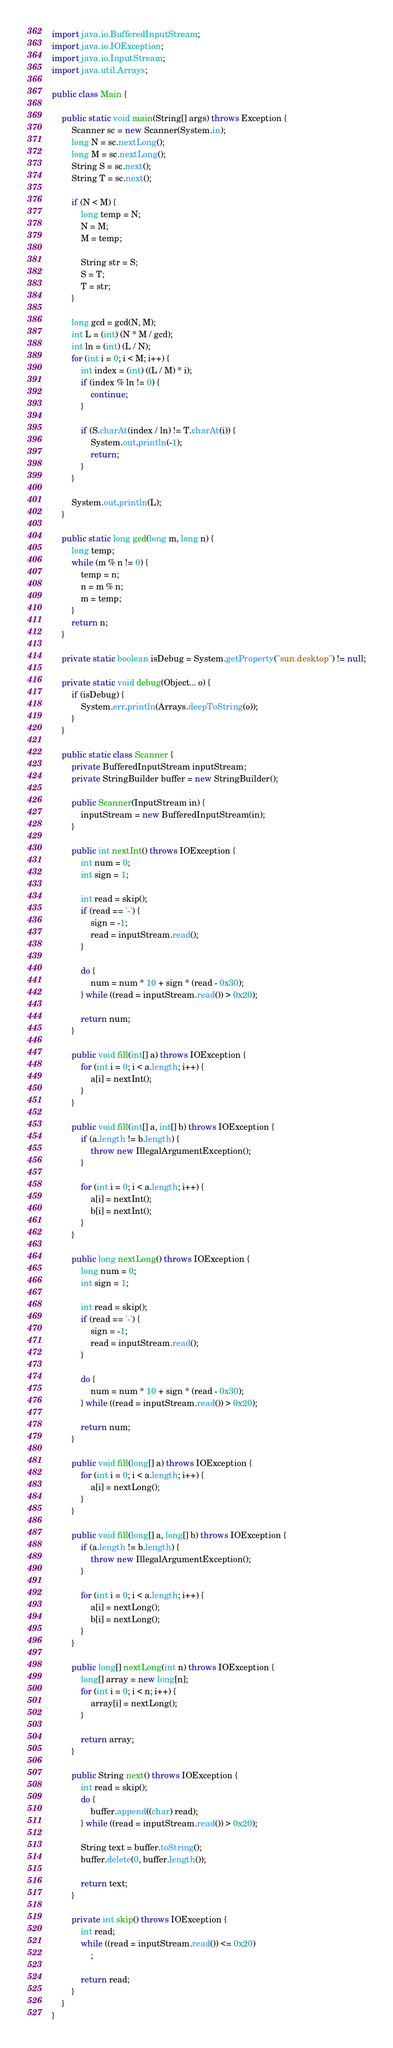<code> <loc_0><loc_0><loc_500><loc_500><_Java_>import java.io.BufferedInputStream;
import java.io.IOException;
import java.io.InputStream;
import java.util.Arrays;

public class Main {

	public static void main(String[] args) throws Exception {
		Scanner sc = new Scanner(System.in);
		long N = sc.nextLong();
		long M = sc.nextLong();
		String S = sc.next();
		String T = sc.next();

		if (N < M) {
			long temp = N;
			N = M;
			M = temp;

			String str = S;
			S = T;
			T = str;
		}

		long gcd = gcd(N, M);
		int L = (int) (N * M / gcd);
		int ln = (int) (L / N);
		for (int i = 0; i < M; i++) {
			int index = (int) ((L / M) * i);
			if (index % ln != 0) {
				continue;
			}

			if (S.charAt(index / ln) != T.charAt(i)) {
				System.out.println(-1);
				return;
			}
		}

		System.out.println(L);
	}

	public static long gcd(long m, long n) {
		long temp;
		while (m % n != 0) {
			temp = n;
			n = m % n;
			m = temp;
		}
		return n;
	}

	private static boolean isDebug = System.getProperty("sun.desktop") != null;

	private static void debug(Object... o) {
		if (isDebug) {
			System.err.println(Arrays.deepToString(o));
		}
	}

	public static class Scanner {
		private BufferedInputStream inputStream;
		private StringBuilder buffer = new StringBuilder();

		public Scanner(InputStream in) {
			inputStream = new BufferedInputStream(in);
		}

		public int nextInt() throws IOException {
			int num = 0;
			int sign = 1;

			int read = skip();
			if (read == '-') {
				sign = -1;
				read = inputStream.read();
			}

			do {
				num = num * 10 + sign * (read - 0x30);
			} while ((read = inputStream.read()) > 0x20);

			return num;
		}

		public void fill(int[] a) throws IOException {
			for (int i = 0; i < a.length; i++) {
				a[i] = nextInt();
			}
		}

		public void fill(int[] a, int[] b) throws IOException {
			if (a.length != b.length) {
				throw new IllegalArgumentException();
			}

			for (int i = 0; i < a.length; i++) {
				a[i] = nextInt();
				b[i] = nextInt();
			}
		}

		public long nextLong() throws IOException {
			long num = 0;
			int sign = 1;

			int read = skip();
			if (read == '-') {
				sign = -1;
				read = inputStream.read();
			}

			do {
				num = num * 10 + sign * (read - 0x30);
			} while ((read = inputStream.read()) > 0x20);

			return num;
		}

		public void fill(long[] a) throws IOException {
			for (int i = 0; i < a.length; i++) {
				a[i] = nextLong();
			}
		}

		public void fill(long[] a, long[] b) throws IOException {
			if (a.length != b.length) {
				throw new IllegalArgumentException();
			}

			for (int i = 0; i < a.length; i++) {
				a[i] = nextLong();
				b[i] = nextLong();
			}
		}

		public long[] nextLong(int n) throws IOException {
			long[] array = new long[n];
			for (int i = 0; i < n; i++) {
				array[i] = nextLong();
			}

			return array;
		}

		public String next() throws IOException {
			int read = skip();
			do {
				buffer.append((char) read);
			} while ((read = inputStream.read()) > 0x20);

			String text = buffer.toString();
			buffer.delete(0, buffer.length());

			return text;
		}

		private int skip() throws IOException {
			int read;
			while ((read = inputStream.read()) <= 0x20)
				;

			return read;
		}
	}
}
</code> 